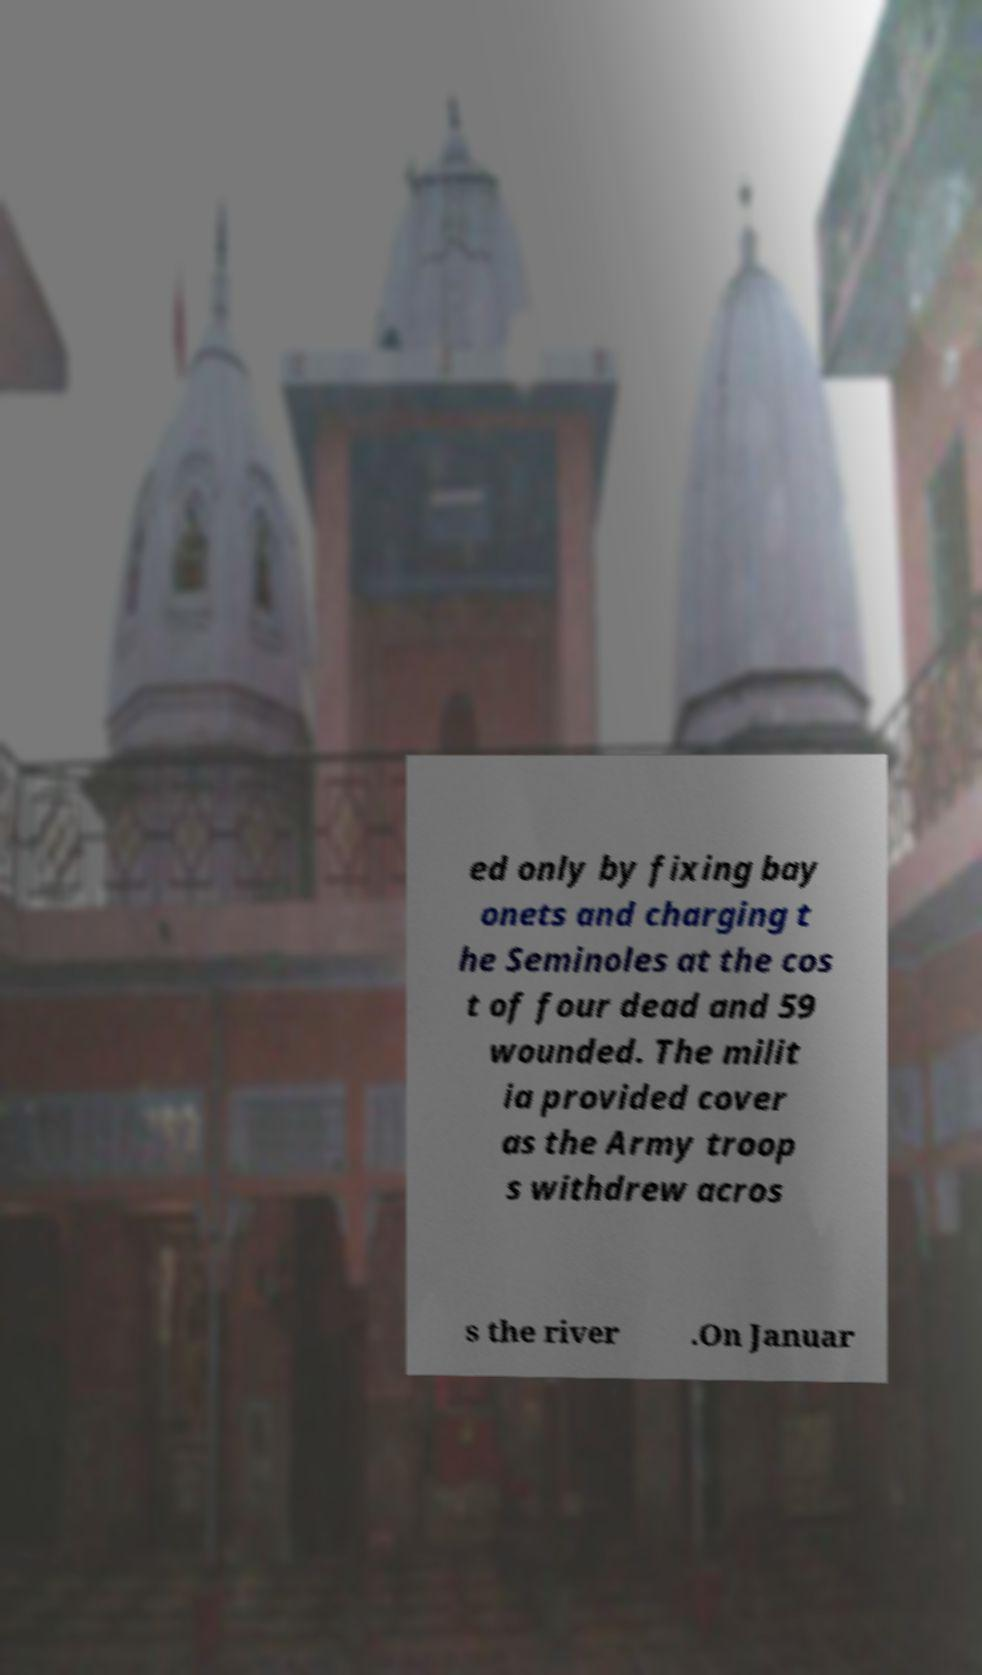Can you accurately transcribe the text from the provided image for me? ed only by fixing bay onets and charging t he Seminoles at the cos t of four dead and 59 wounded. The milit ia provided cover as the Army troop s withdrew acros s the river .On Januar 